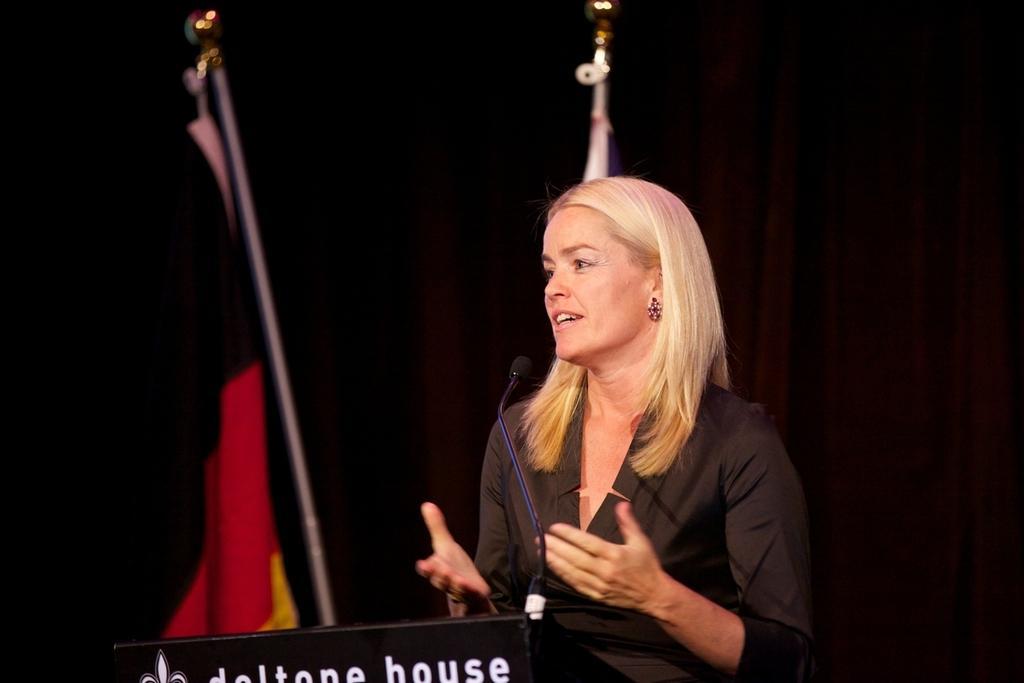Please provide a concise description of this image. In this picture there is a lady in the center of the image and there is a mic and a desk in front of her, there is a black color curtain in the background area of the image. 